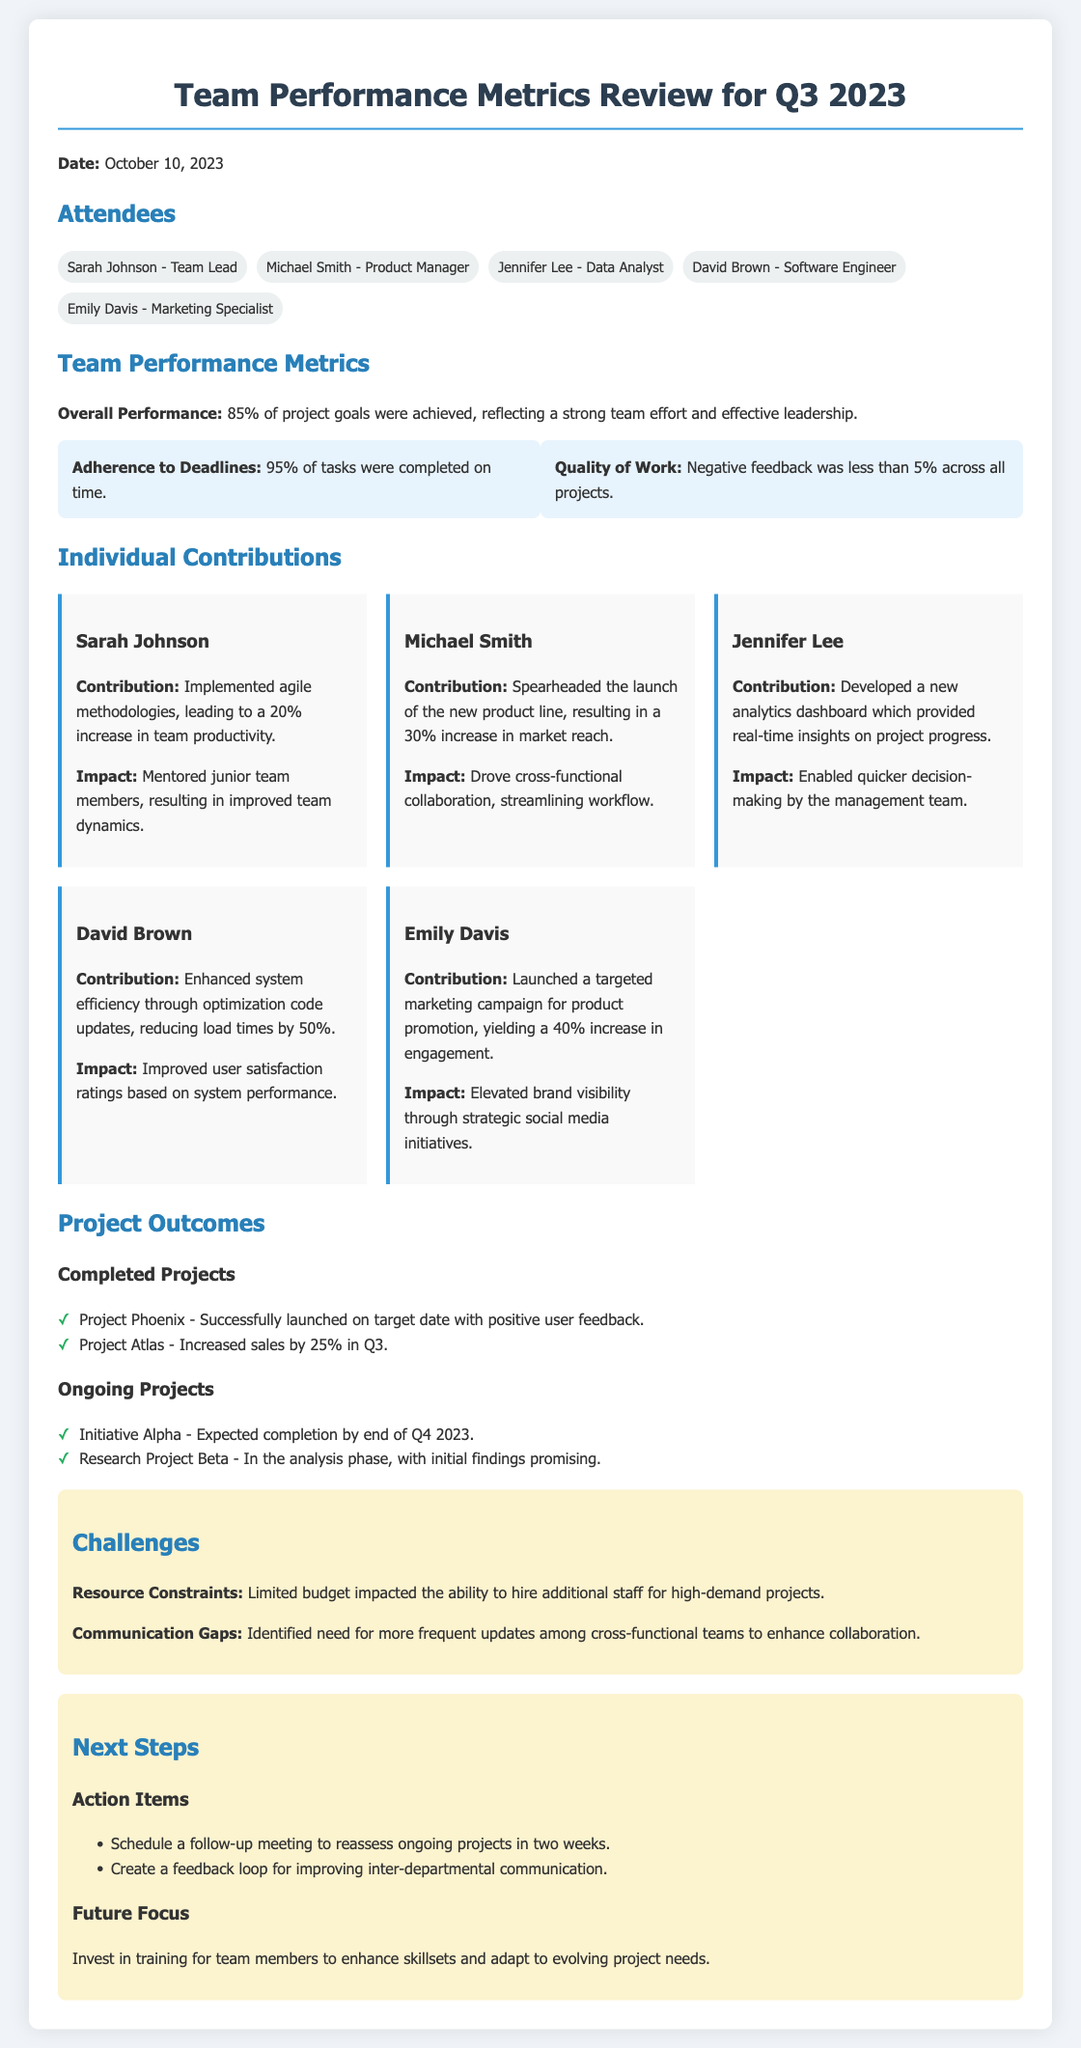What was the overall performance percentage of project goals achieved? The overall performance percentage is noted in the document, indicating the team's success in meeting project goals.
Answer: 85% Who is the team lead? The team lead is mentioned in the attendees section, stating the individual leading the team.
Answer: Sarah Johnson What increase in productivity did Sarah Johnson's agile methodologies lead to? The document specifies the impact of Sarah's contributions, including a specific percentage increase in productivity.
Answer: 20% How much did the targeted marketing campaign yield in terms of engagement increase? The impact of Emily Davis's marketing campaign is quantified in the document, reflecting its success.
Answer: 40% What is the expected completion date for Initiative Alpha? The document outlines ongoing projects, including their expected completion dates, to track progress.
Answer: End of Q4 2023 What percentage of tasks were completed on time? The document includes a specific metric that tracks adherence to deadlines within the team’s performance.
Answer: 95% What challenge was identified regarding communication? The document highlights a specific challenge, focusing on the need for improvements in team communication.
Answer: Communication Gaps What two action items were suggested for the next steps? The document lists specific action items aimed at enhancing team performance and project tracking.
Answer: Follow-up meeting, feedback loop 